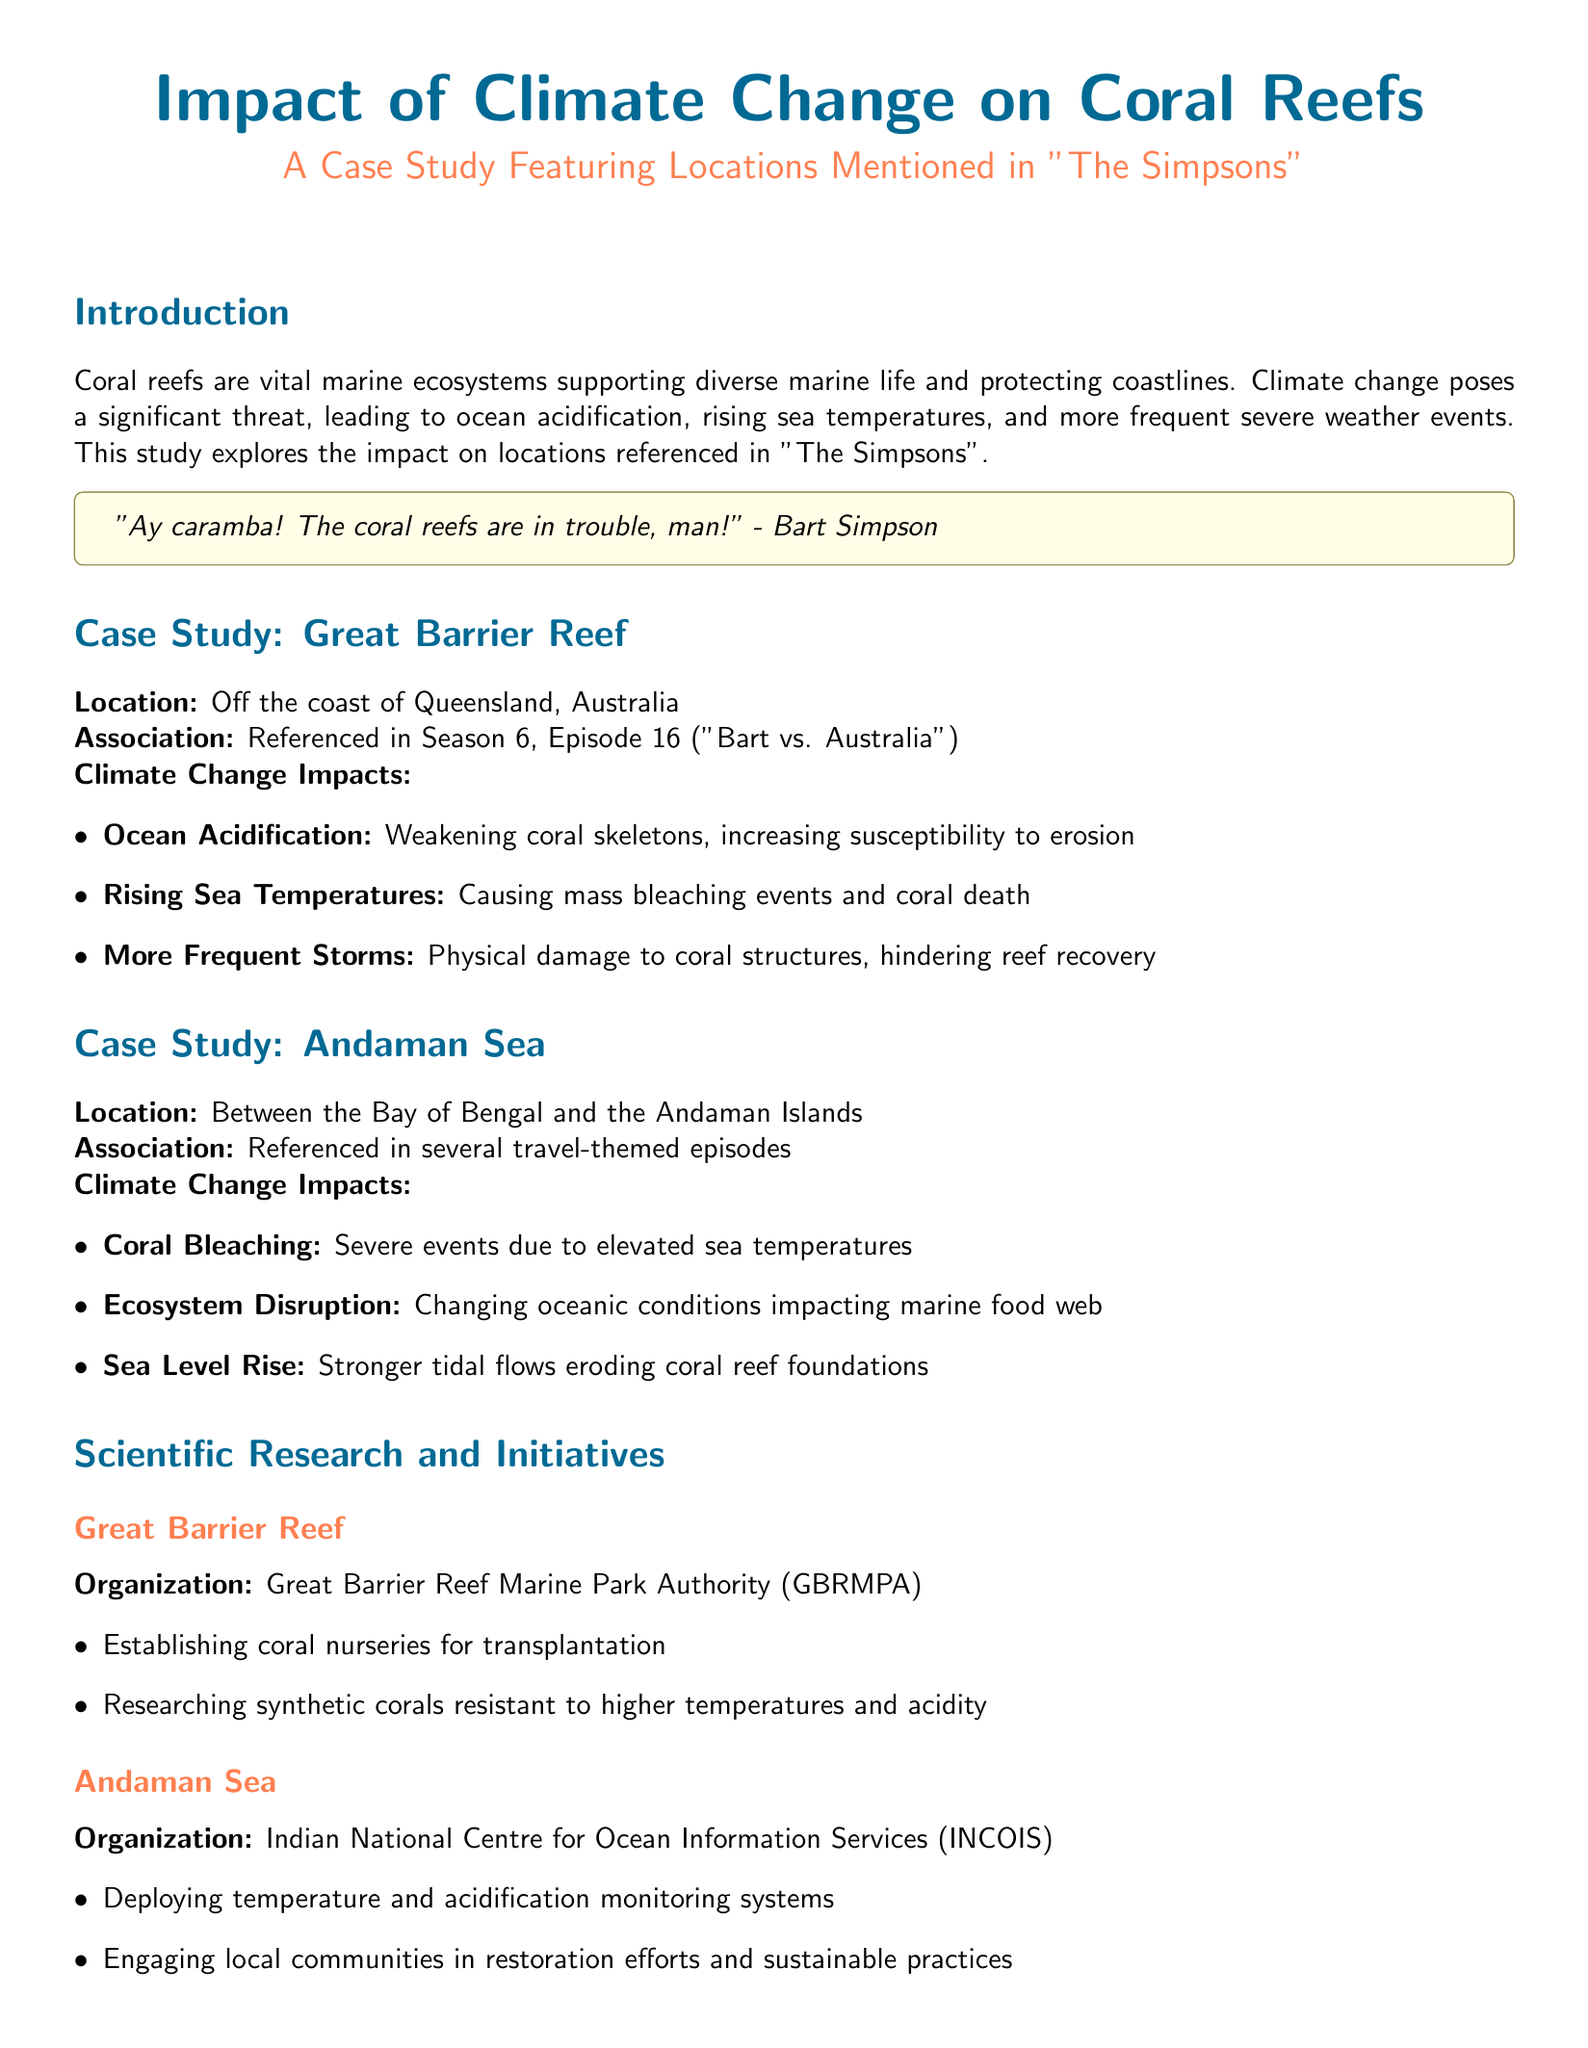What is the title of the case study? The title of the case study is prominently displayed at the beginning of the document.
Answer: Impact of Climate Change on Coral Reefs Which marine ecosystem is discussed in the case study? The document explicitly mentions a specific type of marine ecosystem that is being affected by climate change.
Answer: Coral reefs What organization is involved with the Great Barrier Reef? The document identifies the organization responsible for initiatives related to the Great Barrier Reef.
Answer: Great Barrier Reef Marine Park Authority What climate change impact is characterized by increasing sea temperatures? The document lists several impacts of climate change and specifically mentions this aspect relating to coral.
Answer: Coral Bleaching How many main case studies are featured in the document? The document introduces locations that are specifically analyzed in the study, counting them gives the total.
Answer: Two What quote from which character is referenced in the introduction? The introduction includes a direct quote from a character in "The Simpsons" which highlights concern for the coral reefs.
Answer: "Ay caramba! The coral reefs are in trouble, man!" - Bart Simpson What type of monitoring systems is INCOIS deploying? The document highlights particular systems being put in place in the Andaman Sea, specifically for observing conditions.
Answer: Temperature and acidification monitoring systems What severe weather events affect the coral reefs? The impacts of climate change mentioned in the case studies specifically include the occurrence of certain extreme weather events.
Answer: More Frequent Storms Which sea is mentioned alongside the Great Barrier Reef in the case studies? The document lists various locations, and this is one that is specifically analyzed as well.
Answer: Andaman Sea 